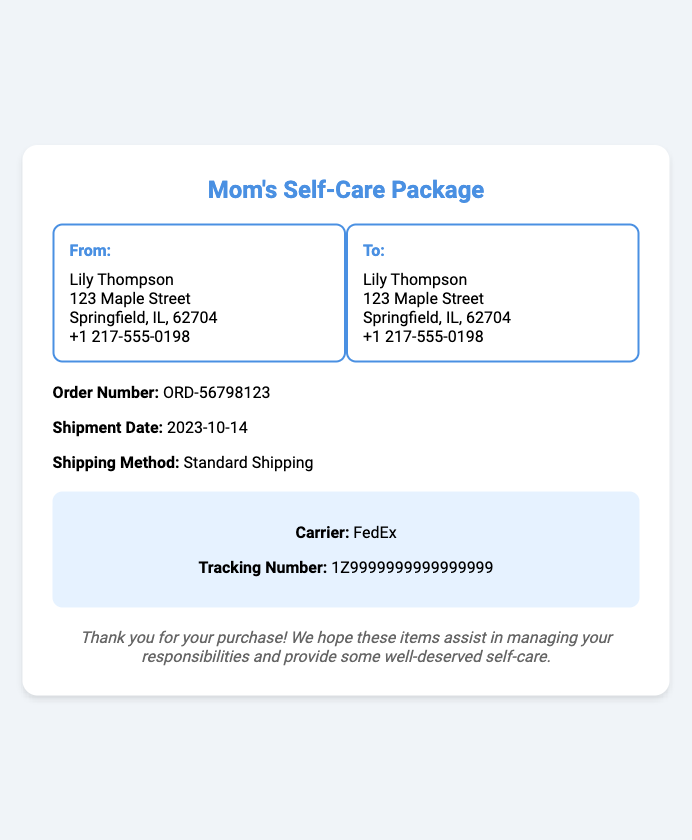What is the order number? The order number is clearly stated in the shipment details section of the document.
Answer: ORD-56798123 What is the shipment date? The shipment date is listed directly under shipment details in the document.
Answer: 2023-10-14 What is the shipping method? The shipping method is specified in the shipment details section of the document.
Answer: Standard Shipping Who is the carrier? The carrier information is provided in the tracking info section of the document.
Answer: FedEx What is the tracking number? The tracking number is mentioned under the tracking info section of the document.
Answer: 1Z9999999999999999 How many items are in the shipment? The document does not specify the number of items, but refers to them generally as self-care items.
Answer: Not specified Who is the sender's contact? The sender's contact information, including name and phone number, is provided in the address box.
Answer: Lily Thompson, +1 217-555-0198 What does the notes section mention? The notes section includes a message related to the purchase and hopes for assistance and self-care.
Answer: Thank you for your purchase! We hope these items assist in managing your responsibilities and provide some well-deserved self-care 